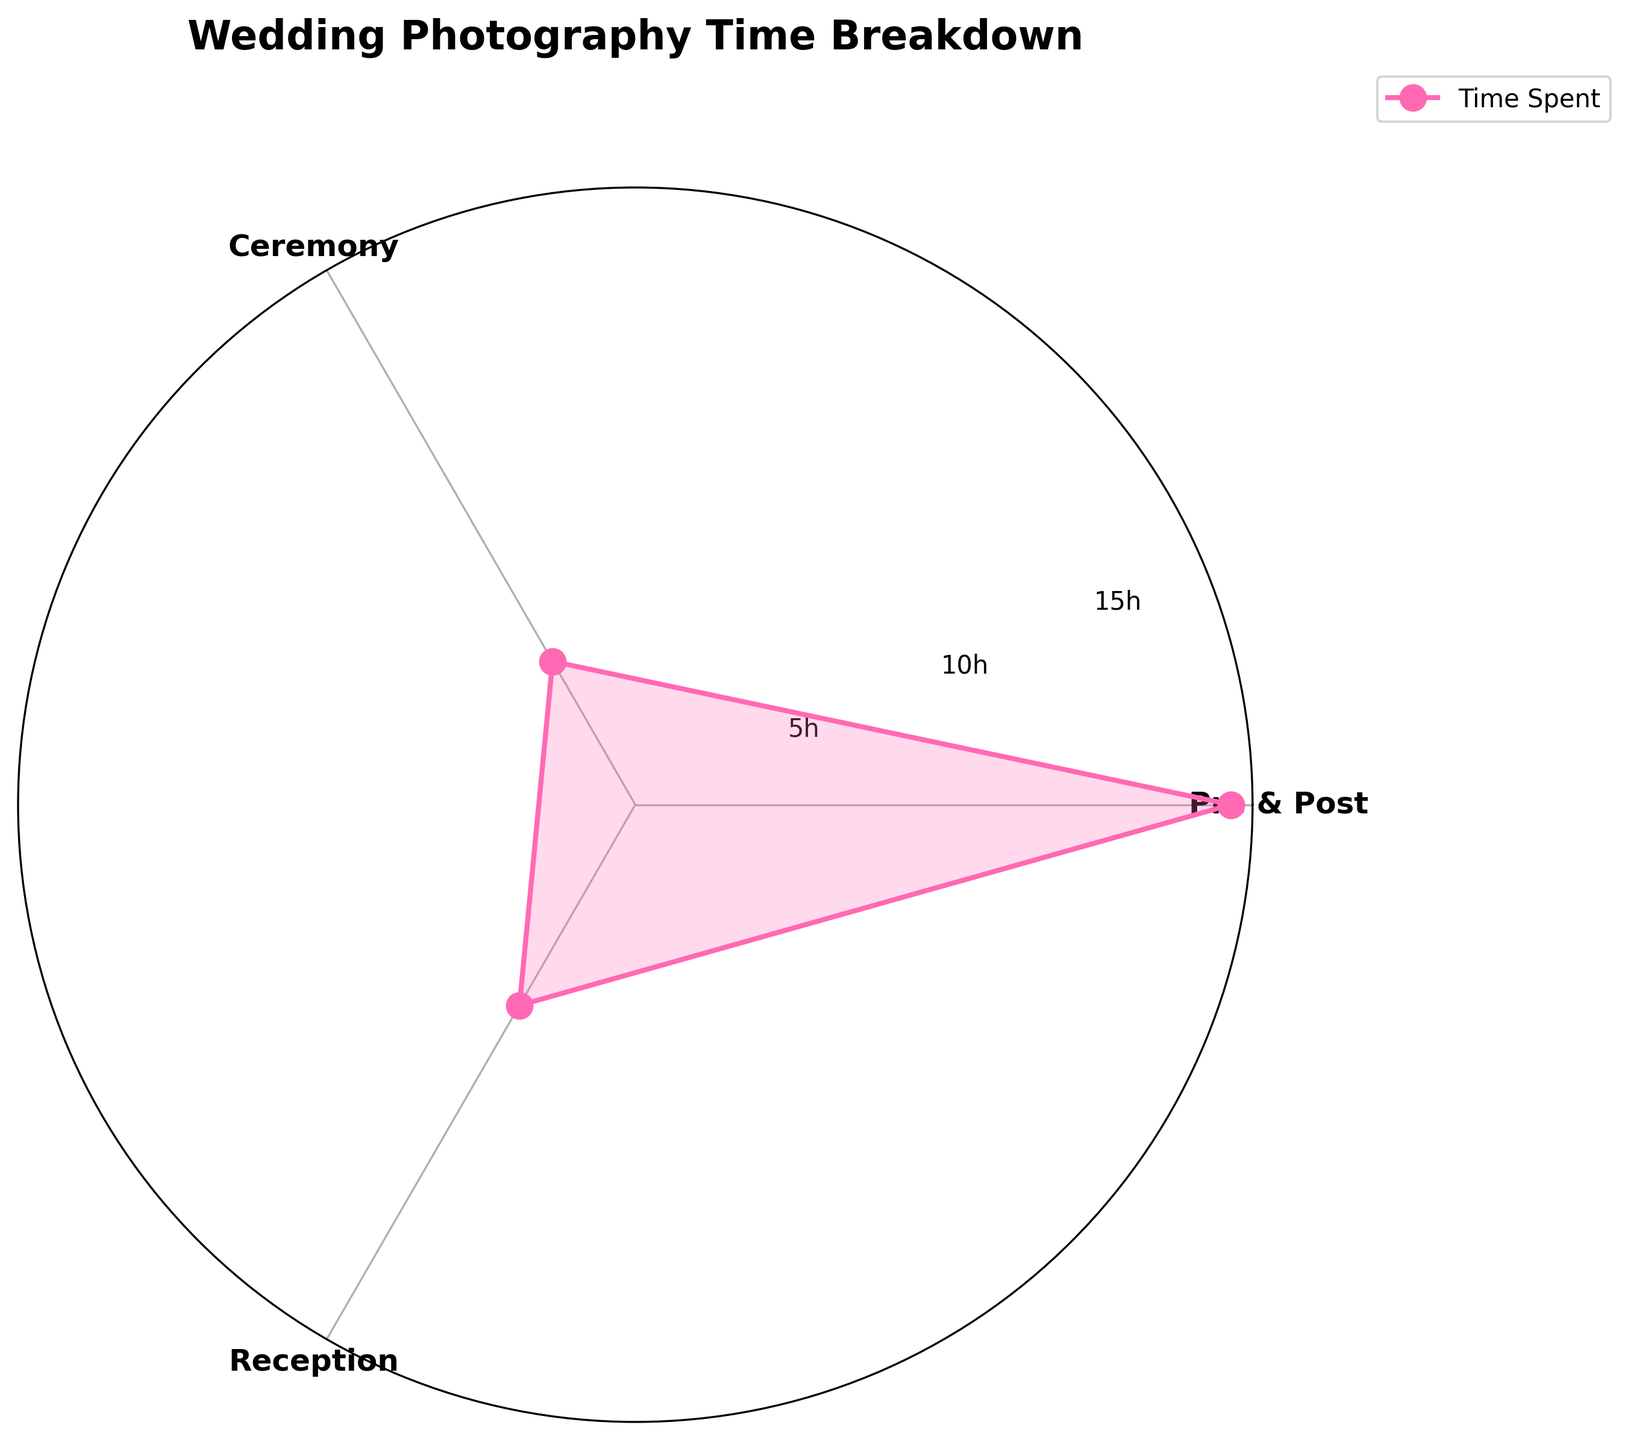Does the chart contain a category named 'Reception'? Yes, 'Reception' is one of the categories labeled on the chart.
Answer: Yes What is the title of the chart? The title is displayed at the top of the chart and reads "Wedding Photography Time Breakdown".
Answer: Wedding Photography Time Breakdown How many hours in total are attributed to 'Pre & Post' services? The 'Pre & Post' category combines the 'Pre-Wedding' and 'Post-Wedding' hours: 10 + 8 = 18 hours.
Answer: 18 hours Which category has the least amount of time spent on it? The visual representation shows that the 'Ceremony' category has the shortest segment compared to others.
Answer: Ceremony What is the difference in time spent between 'Reception' and 'Ceremony'? Subtract the time spent on 'Ceremony' from 'Reception': 7 - 5 = 2 hours.
Answer: 2 hours How many categories are shown in the chart? By visual inspection, there are three categories: 'Pre & Post', 'Ceremony', and 'Reception'.
Answer: 3 Which two categories combined account for more time than 'Pre & Post'? Add the 'Ceremony' and 'Reception' times: 5 + 7 = 12 hours. Since 12 hours is less than 18 hours for 'Pre & Post', no two categories combined account for more time.
Answer: None What do the radar spokes in the chart represent? The radar spokes radiate from the center and represent the different categories: 'Pre & Post', 'Ceremony', and 'Reception'.
Answer: Categories Why is the 'Pre & Post' category time greater than others? It is a combined category that includes both 'Pre-Wedding' (10 hours) and 'Post-Wedding' (8 hours), summing up to 18 hours.
Answer: Combined category (18 hours) 